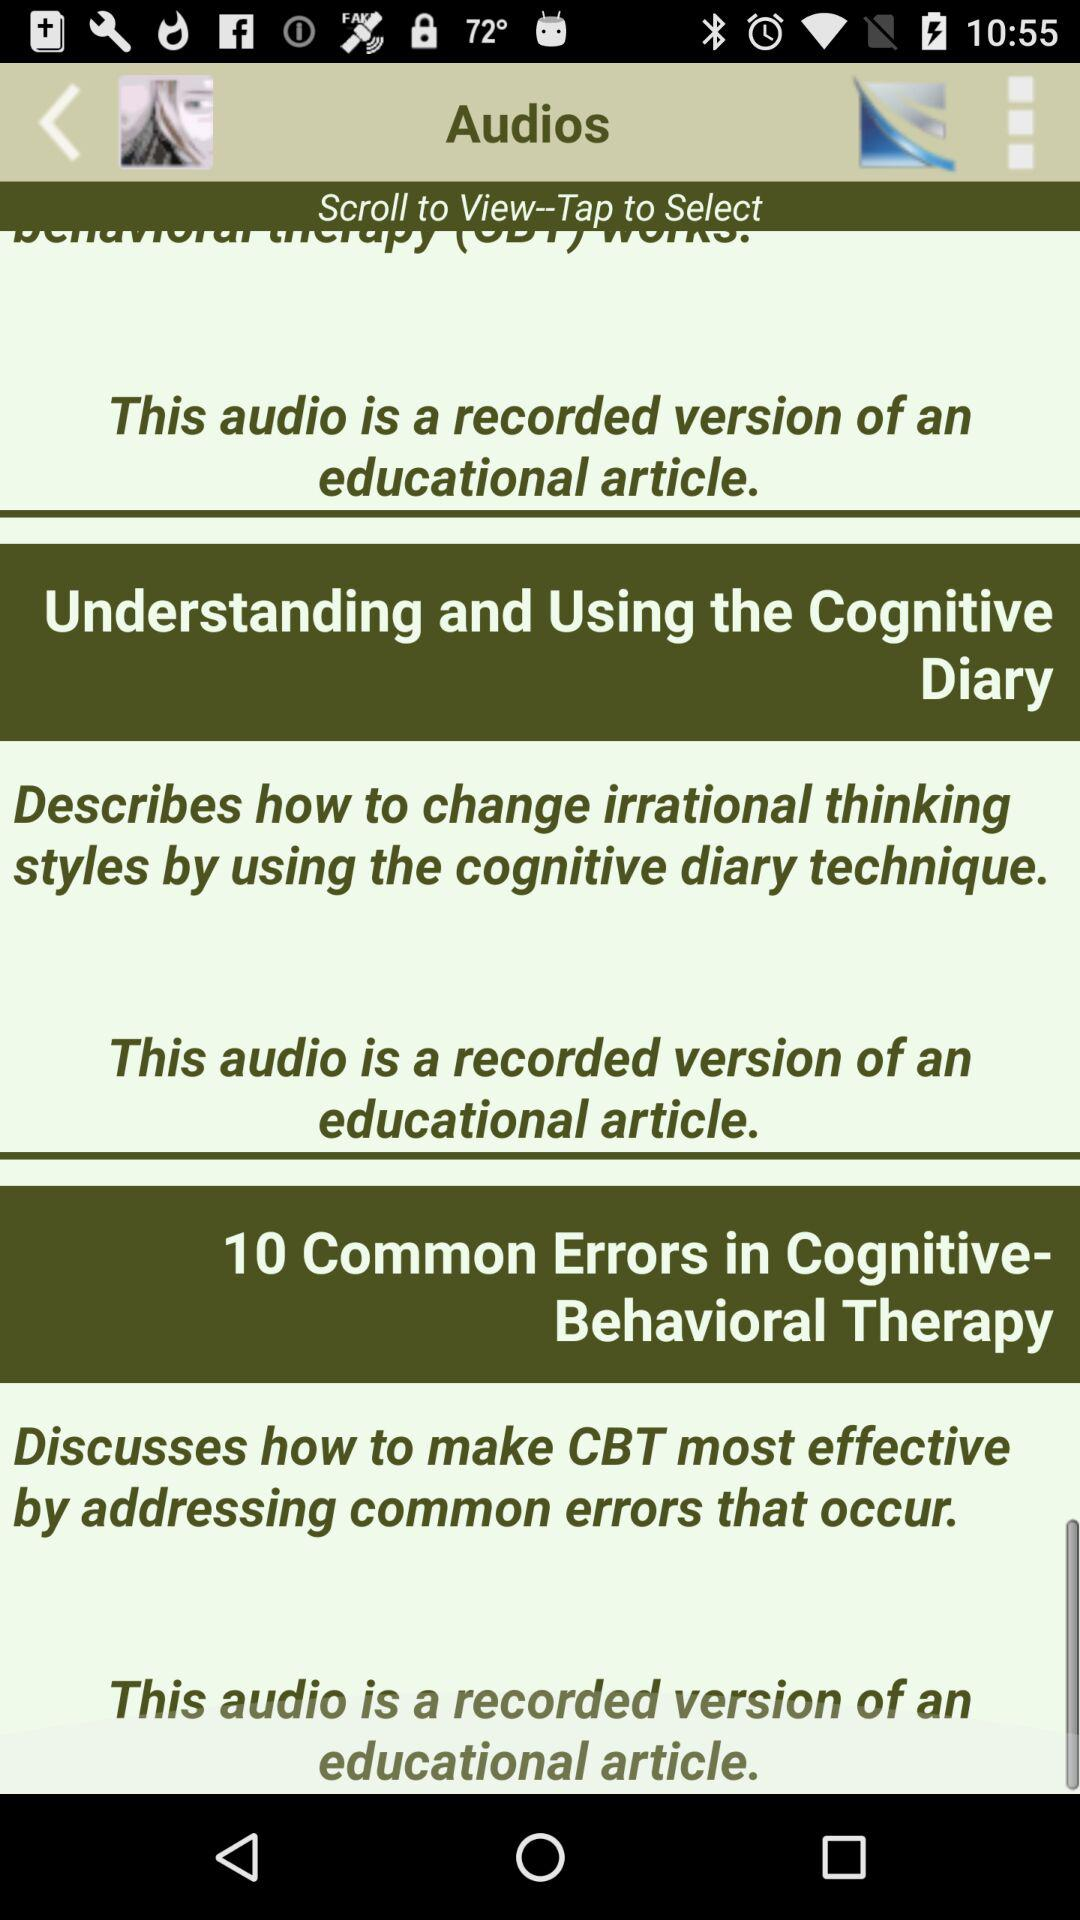How many common errors are there in cognitive-behavioral therapy? There are 10 errors in cognitive-behavioral therapy. 